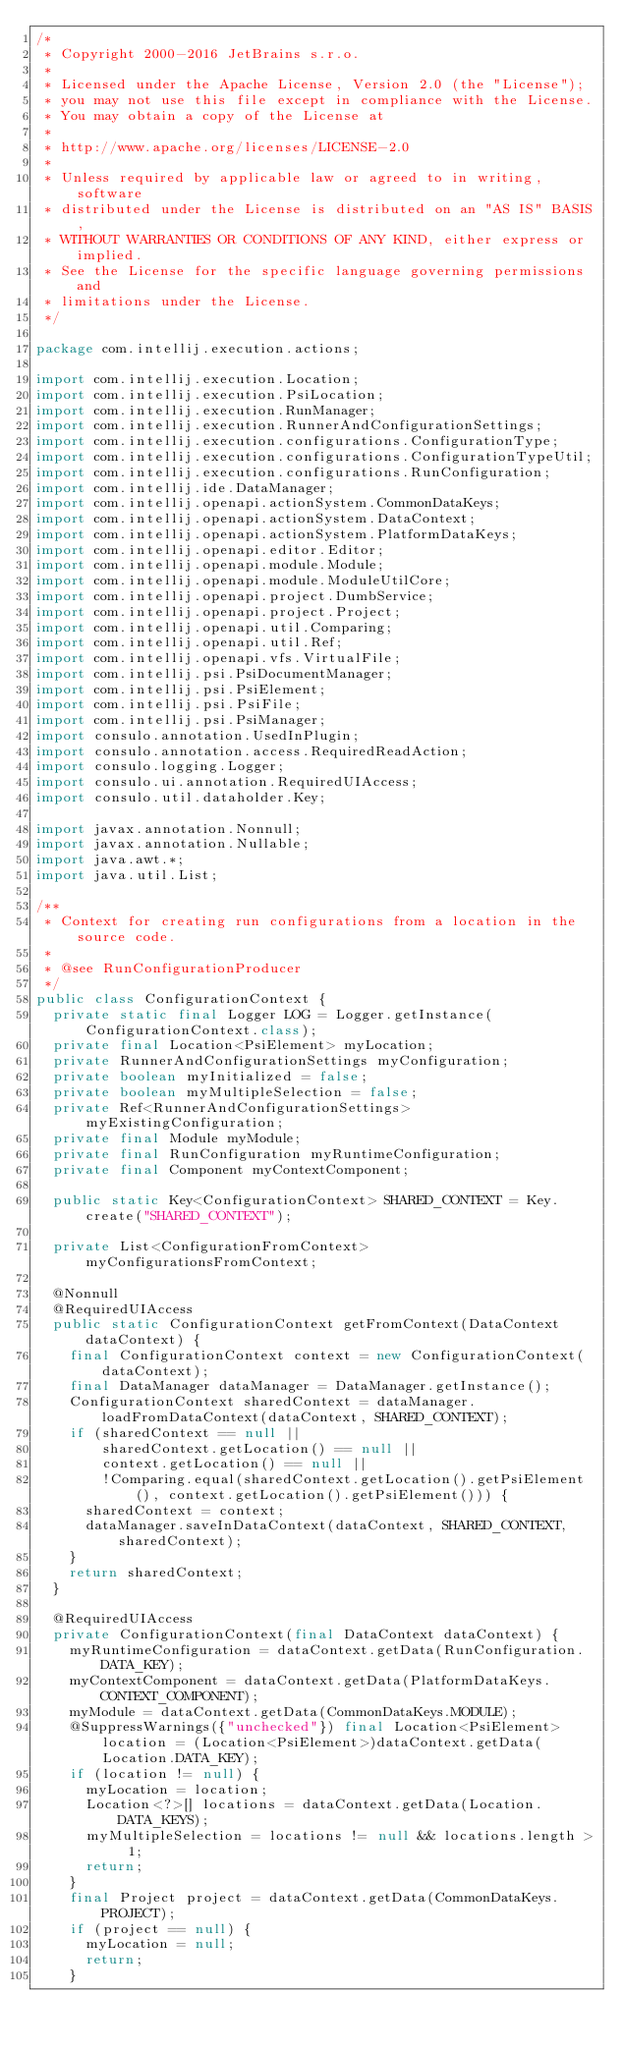<code> <loc_0><loc_0><loc_500><loc_500><_Java_>/*
 * Copyright 2000-2016 JetBrains s.r.o.
 *
 * Licensed under the Apache License, Version 2.0 (the "License");
 * you may not use this file except in compliance with the License.
 * You may obtain a copy of the License at
 *
 * http://www.apache.org/licenses/LICENSE-2.0
 *
 * Unless required by applicable law or agreed to in writing, software
 * distributed under the License is distributed on an "AS IS" BASIS,
 * WITHOUT WARRANTIES OR CONDITIONS OF ANY KIND, either express or implied.
 * See the License for the specific language governing permissions and
 * limitations under the License.
 */

package com.intellij.execution.actions;

import com.intellij.execution.Location;
import com.intellij.execution.PsiLocation;
import com.intellij.execution.RunManager;
import com.intellij.execution.RunnerAndConfigurationSettings;
import com.intellij.execution.configurations.ConfigurationType;
import com.intellij.execution.configurations.ConfigurationTypeUtil;
import com.intellij.execution.configurations.RunConfiguration;
import com.intellij.ide.DataManager;
import com.intellij.openapi.actionSystem.CommonDataKeys;
import com.intellij.openapi.actionSystem.DataContext;
import com.intellij.openapi.actionSystem.PlatformDataKeys;
import com.intellij.openapi.editor.Editor;
import com.intellij.openapi.module.Module;
import com.intellij.openapi.module.ModuleUtilCore;
import com.intellij.openapi.project.DumbService;
import com.intellij.openapi.project.Project;
import com.intellij.openapi.util.Comparing;
import com.intellij.openapi.util.Ref;
import com.intellij.openapi.vfs.VirtualFile;
import com.intellij.psi.PsiDocumentManager;
import com.intellij.psi.PsiElement;
import com.intellij.psi.PsiFile;
import com.intellij.psi.PsiManager;
import consulo.annotation.UsedInPlugin;
import consulo.annotation.access.RequiredReadAction;
import consulo.logging.Logger;
import consulo.ui.annotation.RequiredUIAccess;
import consulo.util.dataholder.Key;

import javax.annotation.Nonnull;
import javax.annotation.Nullable;
import java.awt.*;
import java.util.List;

/**
 * Context for creating run configurations from a location in the source code.
 *
 * @see RunConfigurationProducer
 */
public class ConfigurationContext {
  private static final Logger LOG = Logger.getInstance(ConfigurationContext.class);
  private final Location<PsiElement> myLocation;
  private RunnerAndConfigurationSettings myConfiguration;
  private boolean myInitialized = false;
  private boolean myMultipleSelection = false;
  private Ref<RunnerAndConfigurationSettings> myExistingConfiguration;
  private final Module myModule;
  private final RunConfiguration myRuntimeConfiguration;
  private final Component myContextComponent;

  public static Key<ConfigurationContext> SHARED_CONTEXT = Key.create("SHARED_CONTEXT");

  private List<ConfigurationFromContext> myConfigurationsFromContext;

  @Nonnull
  @RequiredUIAccess
  public static ConfigurationContext getFromContext(DataContext dataContext) {
    final ConfigurationContext context = new ConfigurationContext(dataContext);
    final DataManager dataManager = DataManager.getInstance();
    ConfigurationContext sharedContext = dataManager.loadFromDataContext(dataContext, SHARED_CONTEXT);
    if (sharedContext == null ||
        sharedContext.getLocation() == null ||
        context.getLocation() == null ||
        !Comparing.equal(sharedContext.getLocation().getPsiElement(), context.getLocation().getPsiElement())) {
      sharedContext = context;
      dataManager.saveInDataContext(dataContext, SHARED_CONTEXT, sharedContext);
    }
    return sharedContext;
  }

  @RequiredUIAccess
  private ConfigurationContext(final DataContext dataContext) {
    myRuntimeConfiguration = dataContext.getData(RunConfiguration.DATA_KEY);
    myContextComponent = dataContext.getData(PlatformDataKeys.CONTEXT_COMPONENT);
    myModule = dataContext.getData(CommonDataKeys.MODULE);
    @SuppressWarnings({"unchecked"}) final Location<PsiElement> location = (Location<PsiElement>)dataContext.getData(Location.DATA_KEY);
    if (location != null) {
      myLocation = location;
      Location<?>[] locations = dataContext.getData(Location.DATA_KEYS);
      myMultipleSelection = locations != null && locations.length > 1;
      return;
    }
    final Project project = dataContext.getData(CommonDataKeys.PROJECT);
    if (project == null) {
      myLocation = null;
      return;
    }</code> 